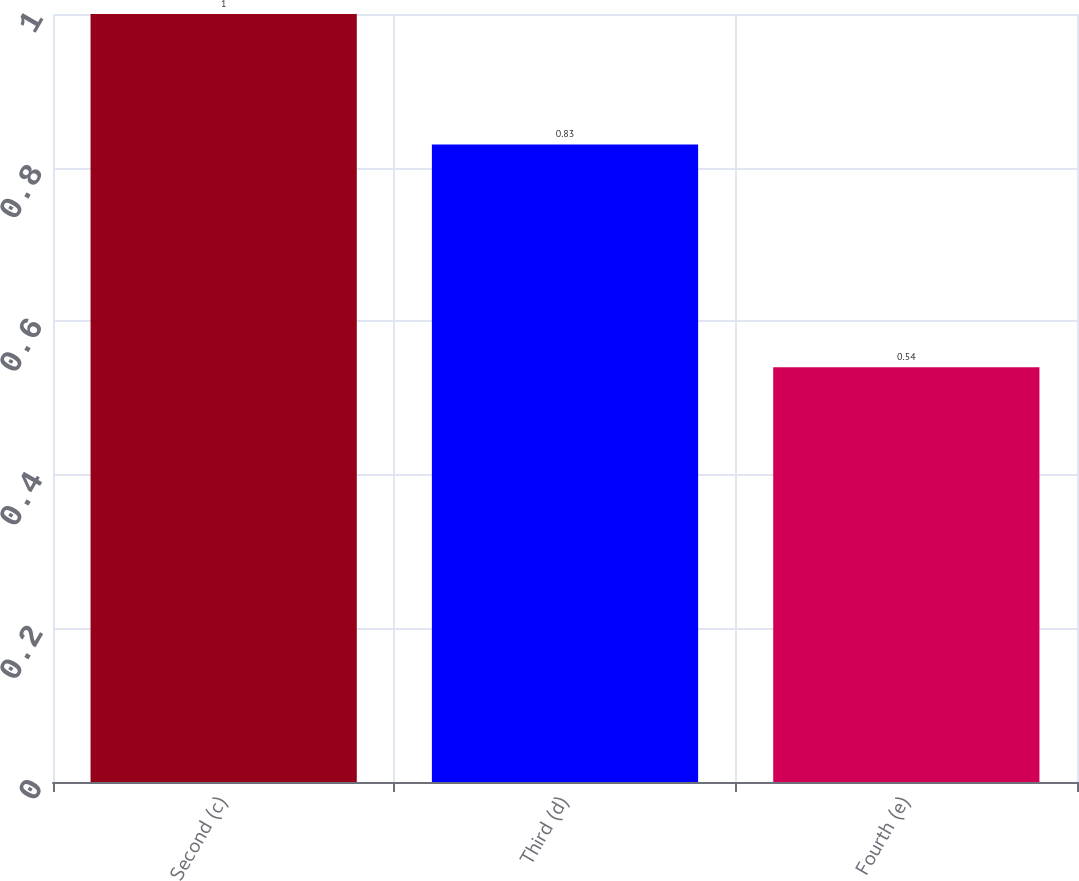Convert chart. <chart><loc_0><loc_0><loc_500><loc_500><bar_chart><fcel>Second (c)<fcel>Third (d)<fcel>Fourth (e)<nl><fcel>1<fcel>0.83<fcel>0.54<nl></chart> 